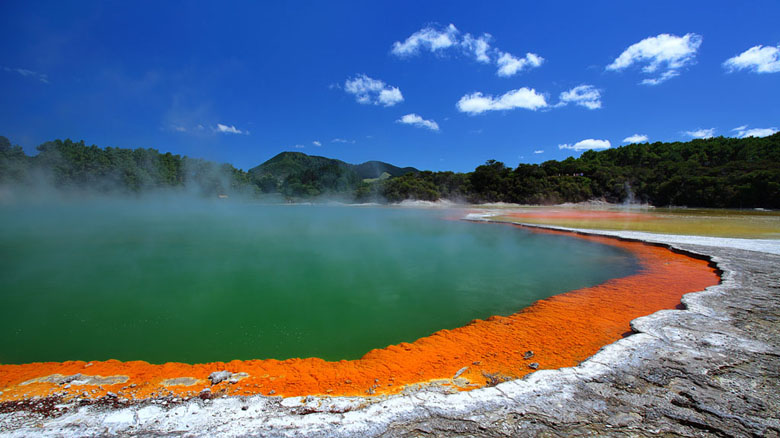How would a casual tourist describe their visit to this hot spring? A casual tourist might say, 'Visiting the Wai-O-Tapu Thermal Wonderland was absolutely stunning. The colors of the hot spring were so vivid and unreal – bright orange edges that transitioned into a deep green center. It felt like I was looking at a painting! The steam rising from the water added a magical touch, and I couldn't stop taking photos. The whole area was surrounded by lush greenery and mountains, making it a perfect spot for nature lovers. It was definitely one of the highlights of my trip to New Zealand.' 